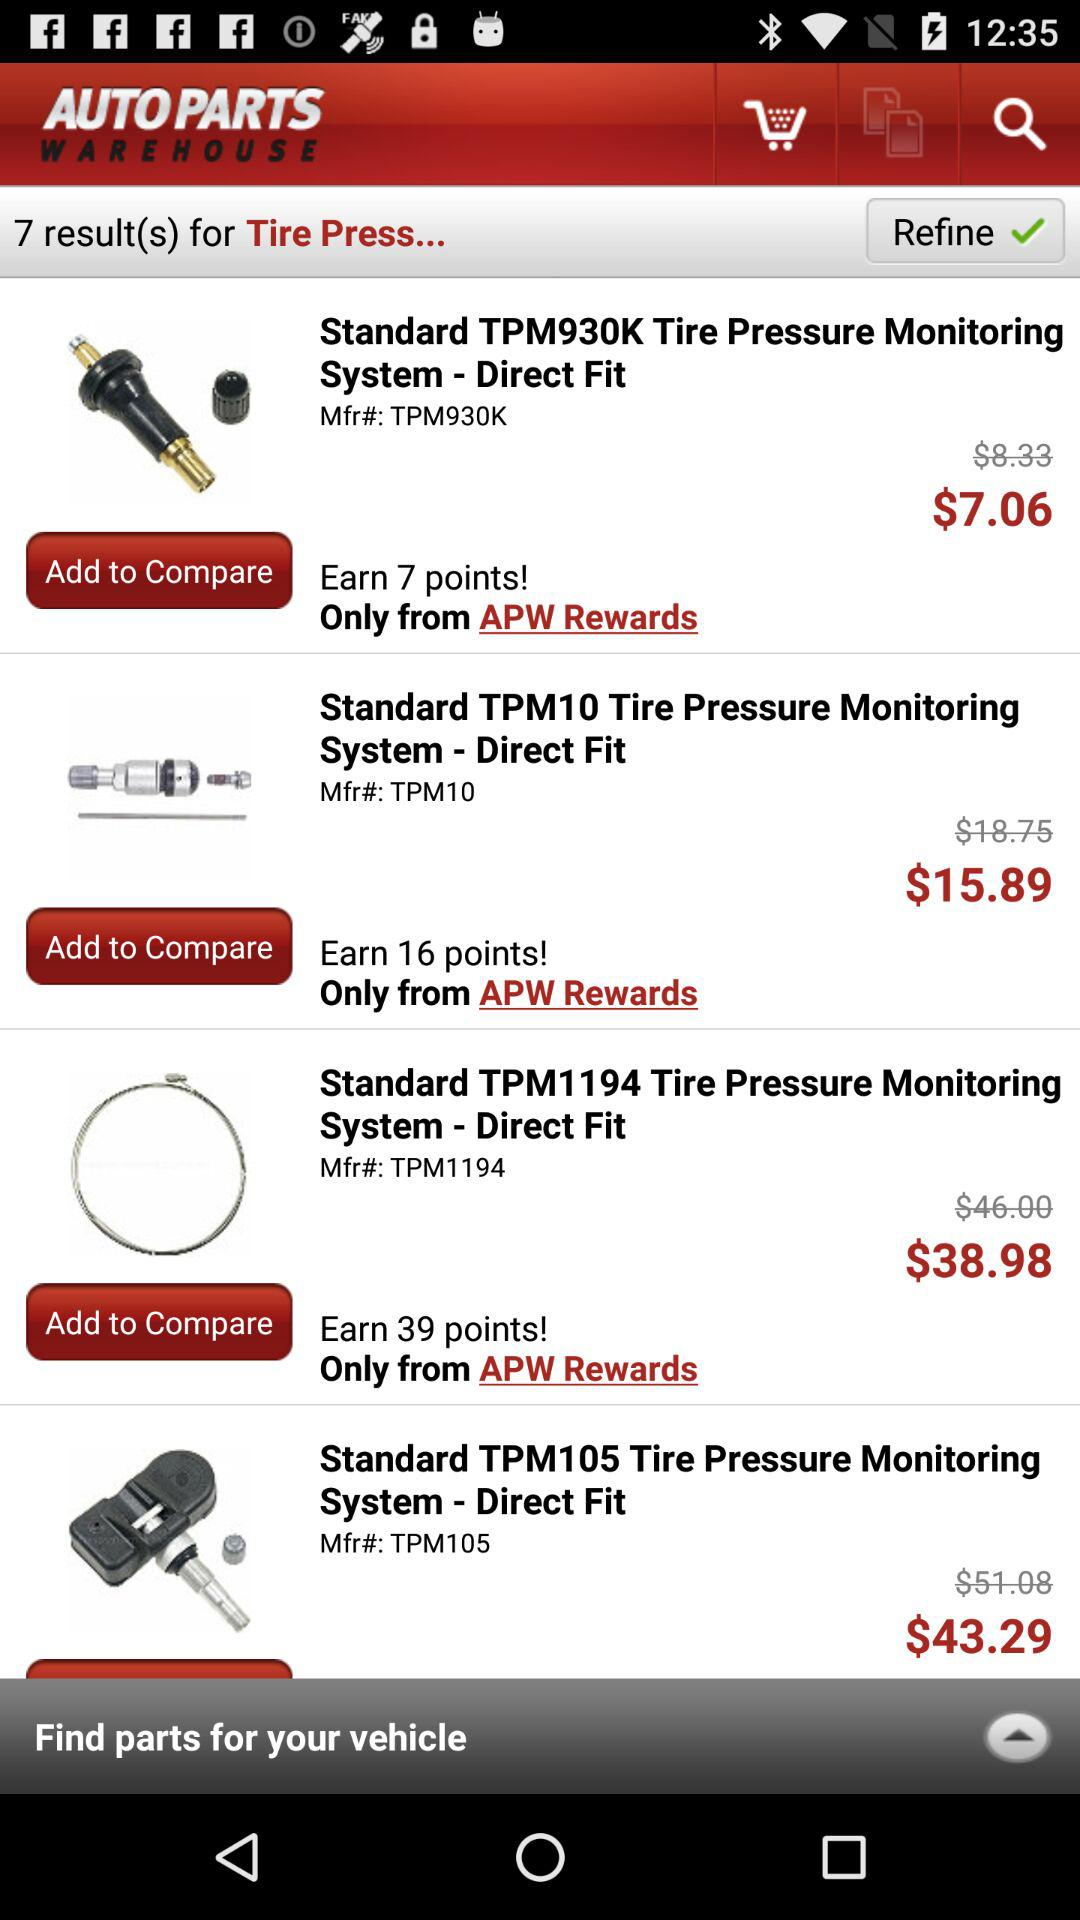How many results are shown here? There are 7 results shown here. 